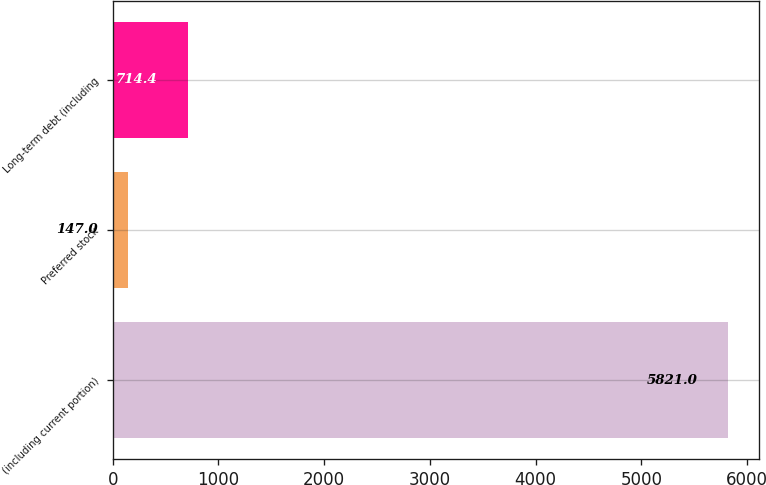Convert chart. <chart><loc_0><loc_0><loc_500><loc_500><bar_chart><fcel>(including current portion)<fcel>Preferred stock<fcel>Long-term debt (including<nl><fcel>5821<fcel>147<fcel>714.4<nl></chart> 